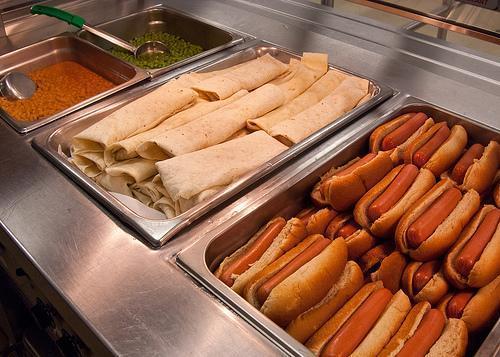How many warming trays are there?
Give a very brief answer. 4. 